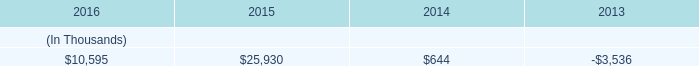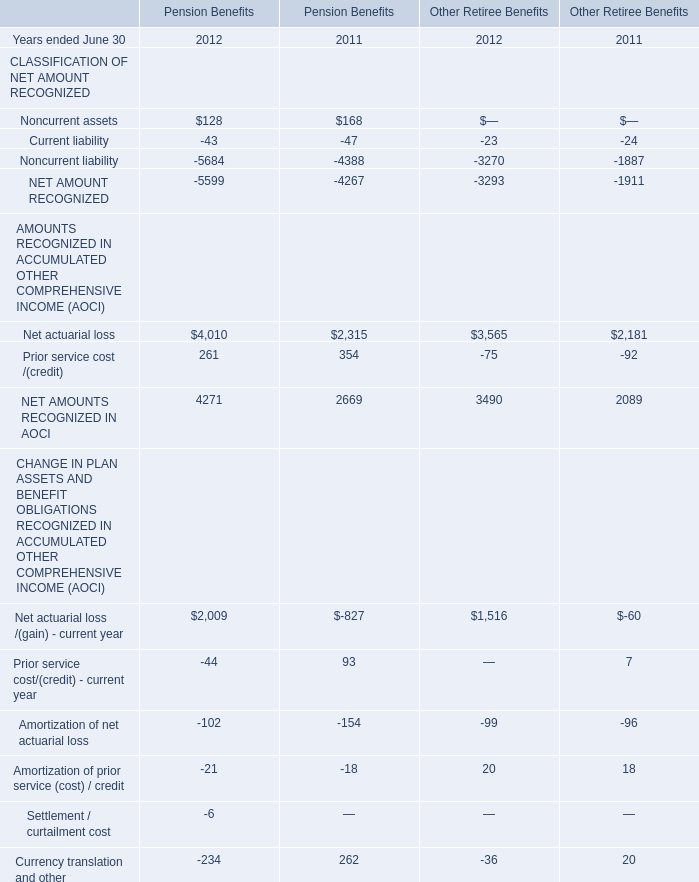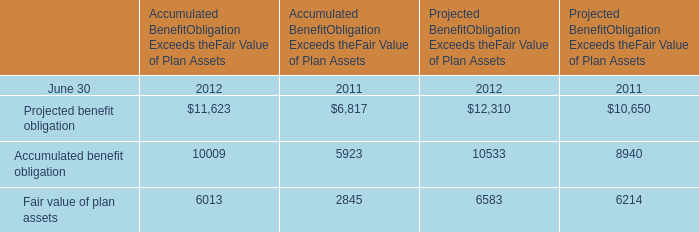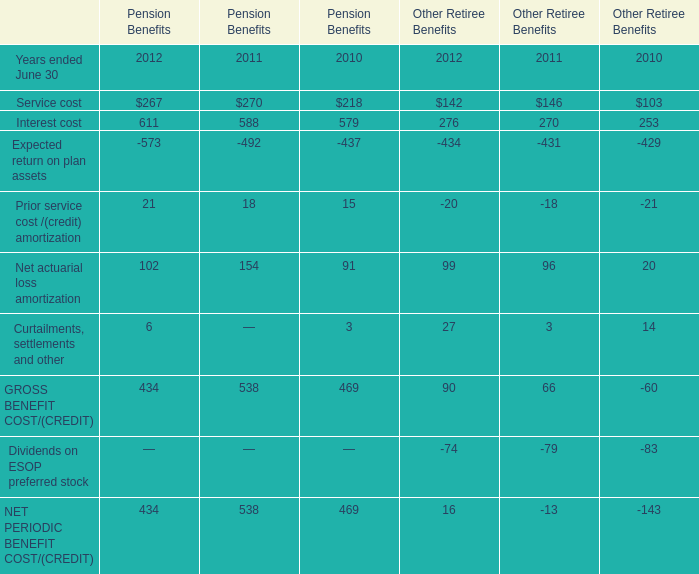What is the ratio of Projected benefit obligation to the total in 2011 for Accumulated Benefit Obligation Exceeds the Fair Value of Plan Assets ? (in %) 
Computations: (6817 / ((6817 + 5923) + 2845))
Answer: 0.43741. 